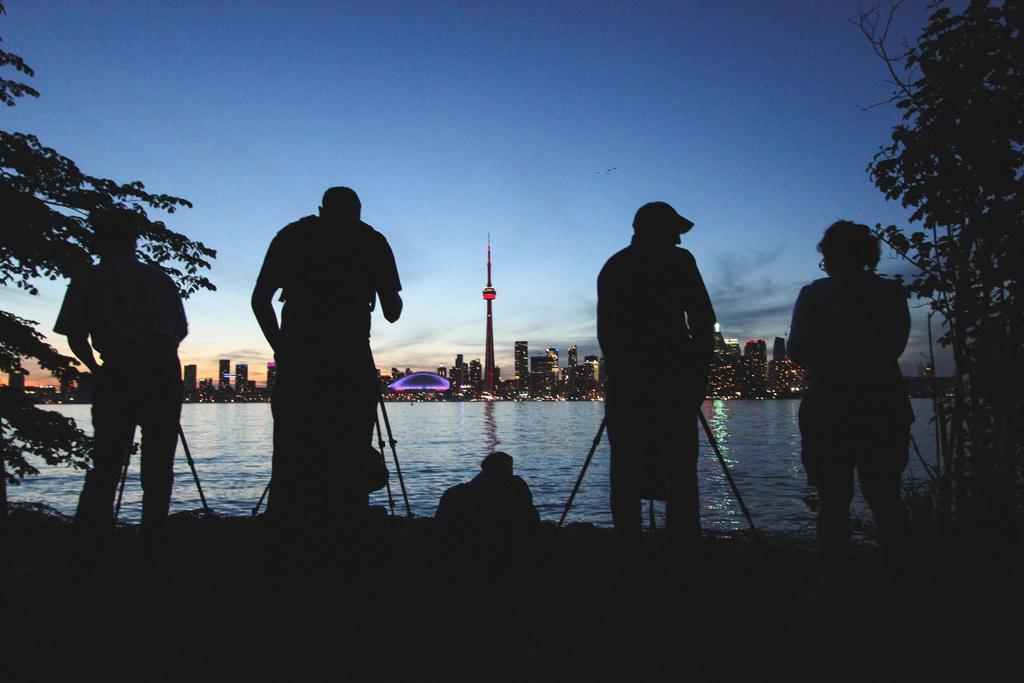How would you summarize this image in a sentence or two? In the image there are few persons standing with camera and tripod in front of them and in the back there are many buildings in front of lake and above its sky. 